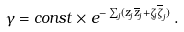Convert formula to latex. <formula><loc_0><loc_0><loc_500><loc_500>\gamma = c o n s t \times e ^ { - \sum _ { j } ( z _ { j } \overline { z } _ { j } + \zeta _ { j } \overline { \zeta } _ { j } ) } \, .</formula> 